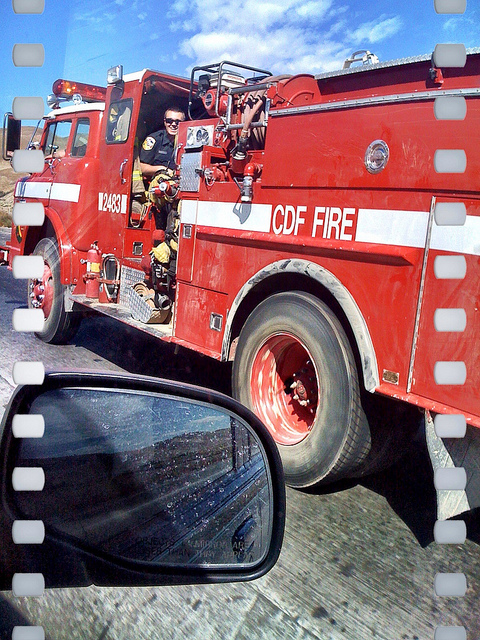How can you tell this is a fire truck and not a regular truck? There are several indicators that this is a fire truck: the bright red color which is traditionally associated with fire services, the word 'FIRE' prominently displayed on the vehicle, the presence of firefighters in uniform, and specialized equipment visible on the truck, all consistent with what one would expect to find on a fire department vehicle. 